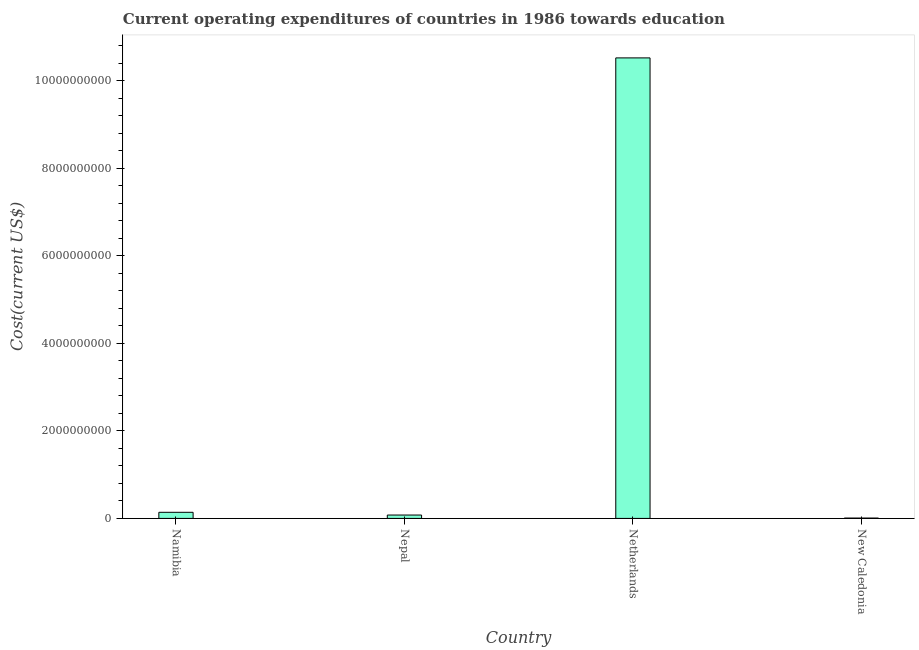Does the graph contain any zero values?
Make the answer very short. No. What is the title of the graph?
Your response must be concise. Current operating expenditures of countries in 1986 towards education. What is the label or title of the X-axis?
Provide a short and direct response. Country. What is the label or title of the Y-axis?
Your response must be concise. Cost(current US$). What is the education expenditure in Nepal?
Your answer should be compact. 7.70e+07. Across all countries, what is the maximum education expenditure?
Ensure brevity in your answer.  1.05e+1. Across all countries, what is the minimum education expenditure?
Your answer should be very brief. 7.74e+06. In which country was the education expenditure minimum?
Offer a very short reply. New Caledonia. What is the sum of the education expenditure?
Your answer should be very brief. 1.07e+1. What is the difference between the education expenditure in Namibia and New Caledonia?
Provide a short and direct response. 1.32e+08. What is the average education expenditure per country?
Your answer should be compact. 2.69e+09. What is the median education expenditure?
Your answer should be compact. 1.08e+08. What is the ratio of the education expenditure in Namibia to that in Netherlands?
Offer a very short reply. 0.01. Is the education expenditure in Namibia less than that in Nepal?
Keep it short and to the point. No. Is the difference between the education expenditure in Namibia and New Caledonia greater than the difference between any two countries?
Provide a succinct answer. No. What is the difference between the highest and the second highest education expenditure?
Offer a terse response. 1.04e+1. Is the sum of the education expenditure in Namibia and Nepal greater than the maximum education expenditure across all countries?
Provide a short and direct response. No. What is the difference between the highest and the lowest education expenditure?
Your answer should be very brief. 1.05e+1. How many bars are there?
Make the answer very short. 4. What is the difference between two consecutive major ticks on the Y-axis?
Your response must be concise. 2.00e+09. Are the values on the major ticks of Y-axis written in scientific E-notation?
Provide a short and direct response. No. What is the Cost(current US$) of Namibia?
Provide a short and direct response. 1.40e+08. What is the Cost(current US$) of Nepal?
Offer a very short reply. 7.70e+07. What is the Cost(current US$) of Netherlands?
Your answer should be very brief. 1.05e+1. What is the Cost(current US$) of New Caledonia?
Ensure brevity in your answer.  7.74e+06. What is the difference between the Cost(current US$) in Namibia and Nepal?
Provide a short and direct response. 6.27e+07. What is the difference between the Cost(current US$) in Namibia and Netherlands?
Provide a short and direct response. -1.04e+1. What is the difference between the Cost(current US$) in Namibia and New Caledonia?
Ensure brevity in your answer.  1.32e+08. What is the difference between the Cost(current US$) in Nepal and Netherlands?
Your response must be concise. -1.04e+1. What is the difference between the Cost(current US$) in Nepal and New Caledonia?
Your response must be concise. 6.92e+07. What is the difference between the Cost(current US$) in Netherlands and New Caledonia?
Make the answer very short. 1.05e+1. What is the ratio of the Cost(current US$) in Namibia to that in Nepal?
Provide a succinct answer. 1.81. What is the ratio of the Cost(current US$) in Namibia to that in Netherlands?
Offer a terse response. 0.01. What is the ratio of the Cost(current US$) in Namibia to that in New Caledonia?
Your response must be concise. 18.04. What is the ratio of the Cost(current US$) in Nepal to that in Netherlands?
Give a very brief answer. 0.01. What is the ratio of the Cost(current US$) in Nepal to that in New Caledonia?
Ensure brevity in your answer.  9.94. What is the ratio of the Cost(current US$) in Netherlands to that in New Caledonia?
Keep it short and to the point. 1359.12. 